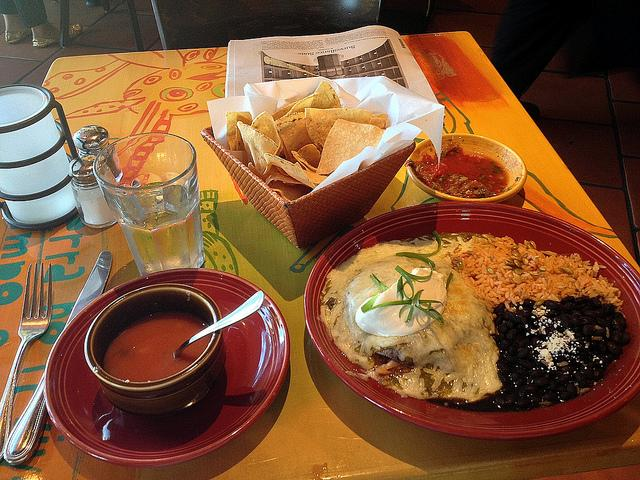How many people will dine at this table?

Choices:
A) two
B) five
C) none
D) one one 